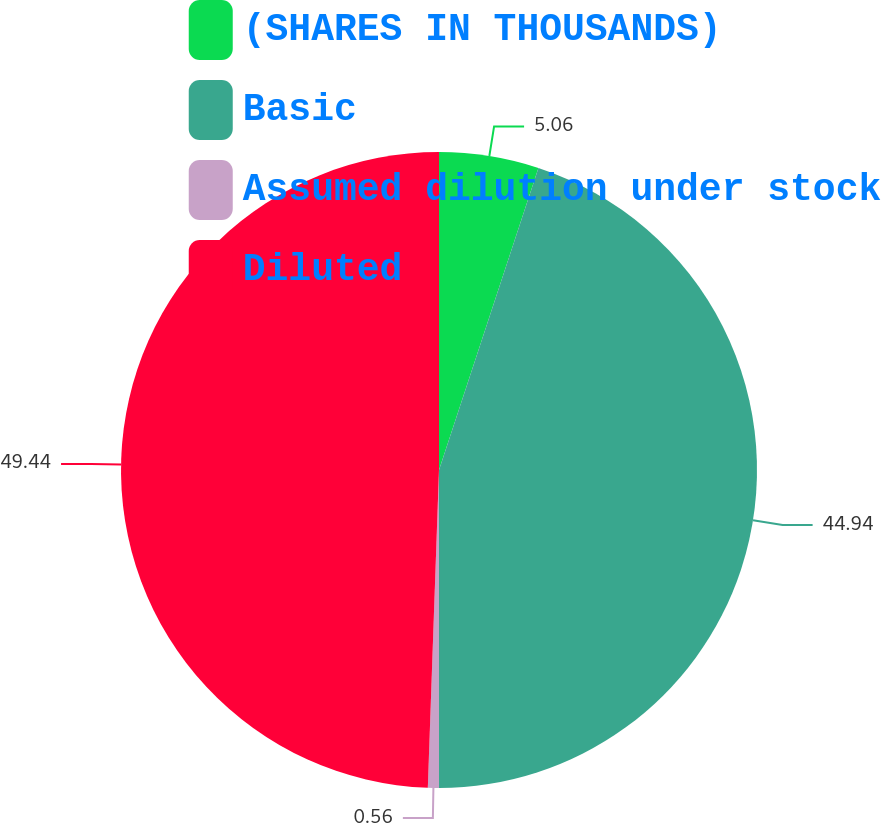Convert chart to OTSL. <chart><loc_0><loc_0><loc_500><loc_500><pie_chart><fcel>(SHARES IN THOUSANDS)<fcel>Basic<fcel>Assumed dilution under stock<fcel>Diluted<nl><fcel>5.06%<fcel>44.94%<fcel>0.56%<fcel>49.44%<nl></chart> 